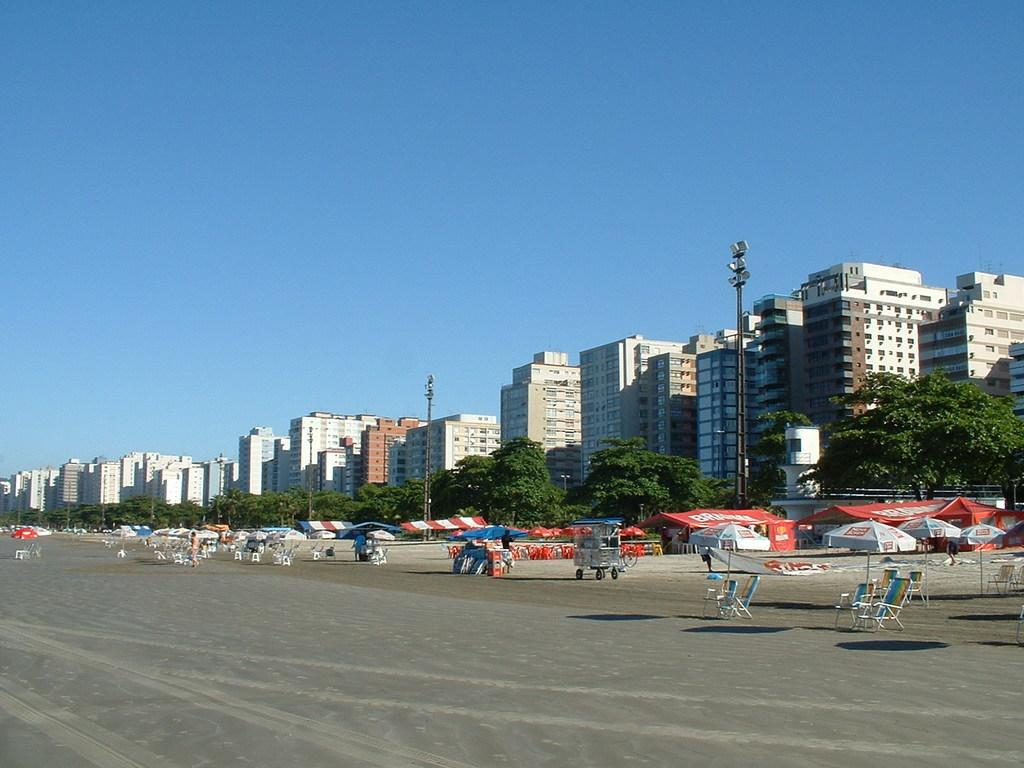What type of furniture can be seen in the image? There are chairs in the image. What type of shade is provided in the image? There are patio umbrellas in the image. What type of vehicle is present in the image? There is a cart in the image. Can you describe the people in the image? There are people in the image. What type of support structures are visible in the image? There are poles in the image. What type of illumination is present in the image? There are lights in the image. What type of structures are visible in the background of the image? There are buildings in the image. What type of vegetation is visible in the image? There are trees in the image. What is visible in the background of the image? The sky is visible in the background of the image. What is the tendency of the chairs to fold in the image? There is no indication in the image that the chairs have a tendency to fold. How does the comfort of the trees affect the people in the image? The trees in the image do not have a direct impact on the comfort of the people; they are separate elements in the scene. 